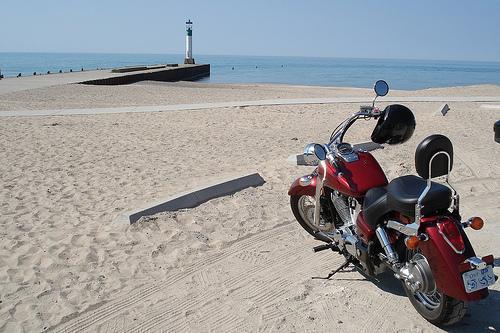How many bikes?
Give a very brief answer. 1. 